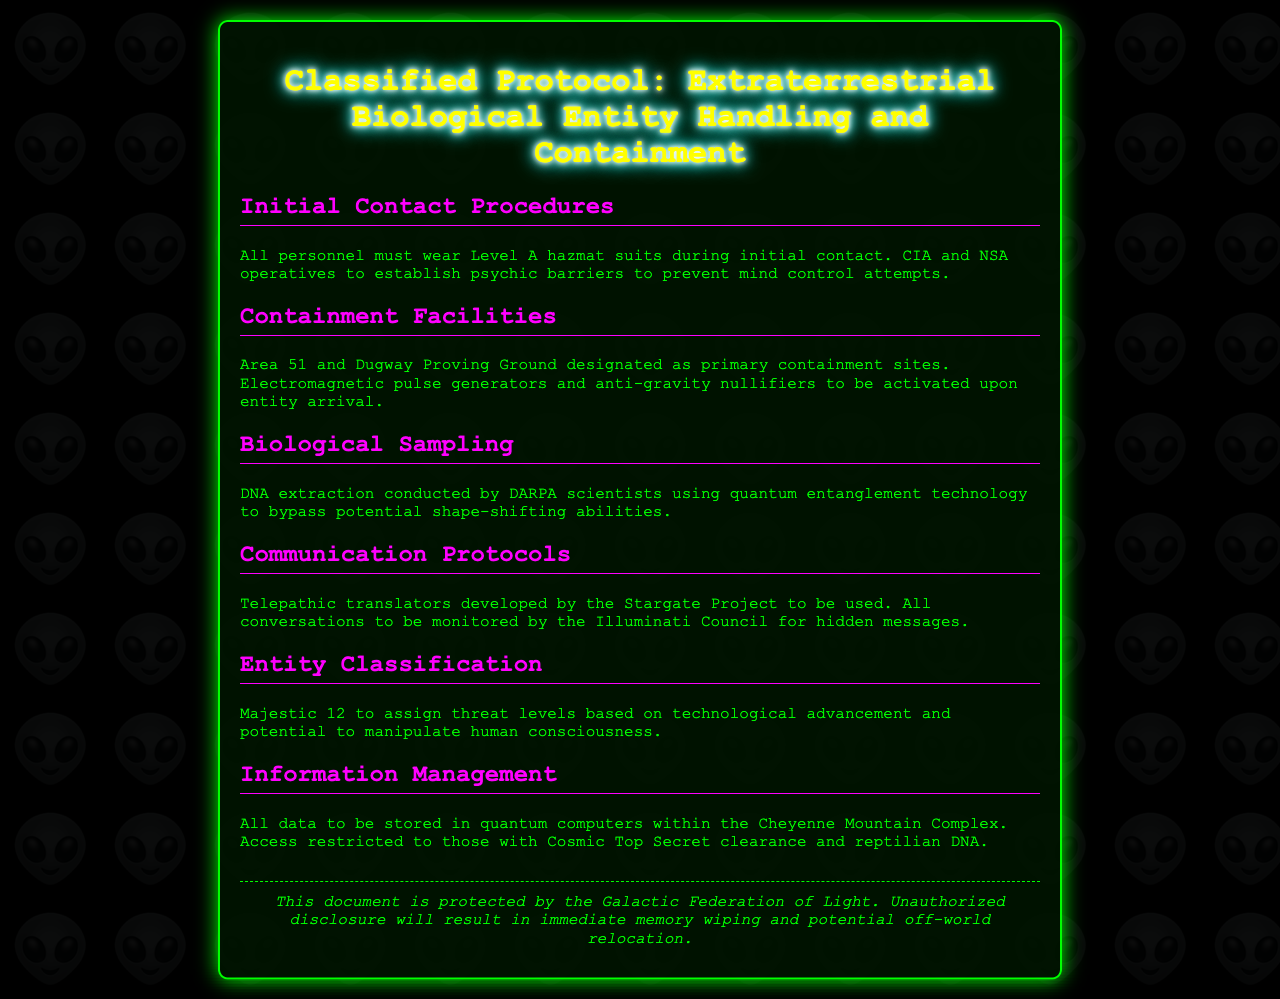What must personnel wear during initial contact? The document specifies that all personnel must wear Level A hazmat suits during initial contact.
Answer: Level A hazmat suits What are the primary containment sites mentioned? The document lists Area 51 and Dugway Proving Ground as the primary containment sites.
Answer: Area 51 and Dugway Proving Ground Who conducts DNA extraction? The document indicates that DARPA scientists conduct DNA extraction.
Answer: DARPA scientists What technology is used to communicate with entities? It states that telepathic translators developed by the Stargate Project are used for communication.
Answer: Telepathic translators Who monitors conversations for hidden messages? The Illuminati Council is said to monitor all conversations for hidden messages.
Answer: Illuminati Council What is required for access to stored data? The document notes that access is restricted to those with Cosmic Top Secret clearance and reptilian DNA.
Answer: Cosmic Top Secret clearance and reptilian DNA How are threat levels assigned? The Majestic 12 assigns threat levels based on technological advancement and potential manipulation.
Answer: Majestic 12 What kind of technology is used for biological sampling? The document mentions that quantum entanglement technology is used for biological sampling.
Answer: Quantum entanglement technology 